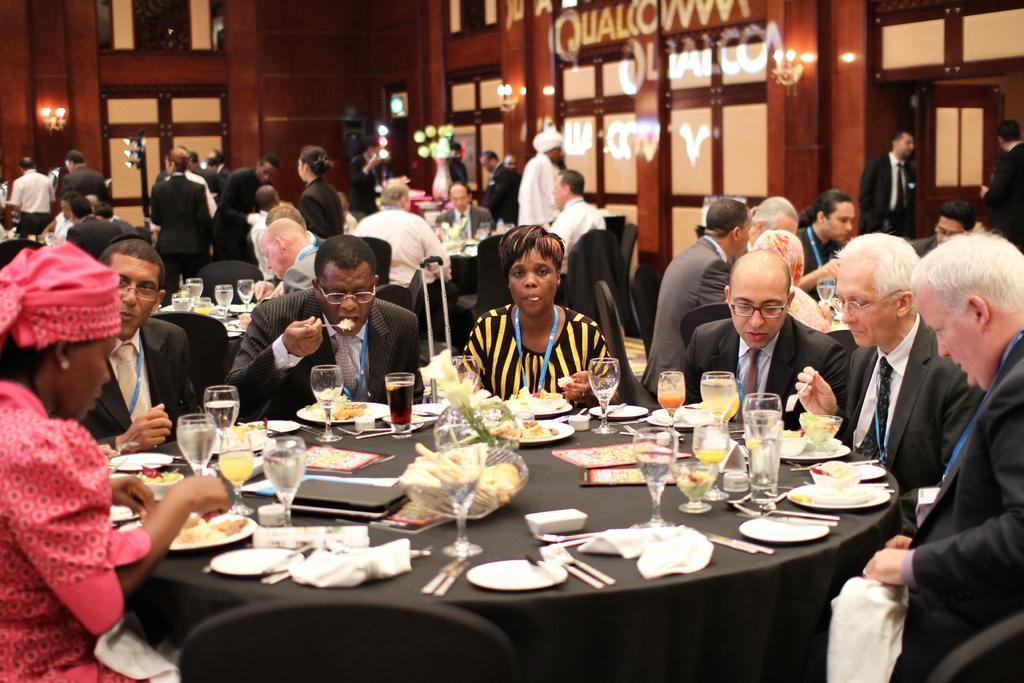Please provide a concise description of this image. In this image there are group of persons who are sitting around the table and having their food and some drinks. At the background of the image there are some persons standing at the foreground of the image there are some food items,spoons,forks,plates,glass on top of the table. 